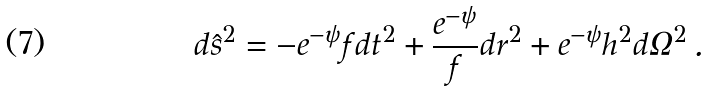Convert formula to latex. <formula><loc_0><loc_0><loc_500><loc_500>d \hat { s } ^ { 2 } = - e ^ { - \psi } f d t ^ { 2 } + \frac { e ^ { - \psi } } { f } d r ^ { 2 } + e ^ { - \psi } h ^ { 2 } d \Omega ^ { 2 } \, .</formula> 